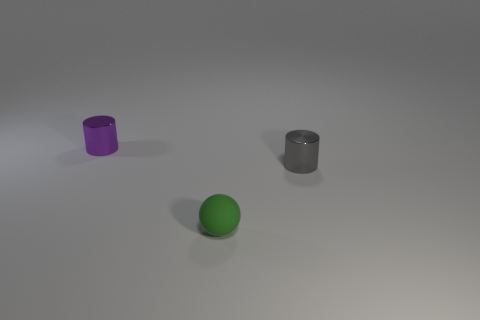Are there fewer purple metallic things that are to the right of the tiny rubber sphere than gray objects?
Ensure brevity in your answer.  Yes. There is a cylinder that is behind the gray metallic object; is it the same size as the green ball?
Your answer should be compact. Yes. How many things are behind the gray metal object and to the right of the tiny green object?
Your answer should be very brief. 0. What size is the cylinder to the right of the small shiny cylinder left of the tiny matte thing?
Your response must be concise. Small. Is the number of gray cylinders that are in front of the small gray cylinder less than the number of shiny cylinders that are right of the green rubber sphere?
Give a very brief answer. Yes. There is a shiny cylinder in front of the purple cylinder; does it have the same color as the cylinder that is to the left of the small green object?
Give a very brief answer. No. There is a object that is in front of the purple object and to the left of the small gray shiny object; what is its material?
Keep it short and to the point. Rubber. Are there any tiny rubber objects?
Offer a very short reply. Yes. What is the shape of the tiny gray object that is the same material as the tiny purple cylinder?
Your answer should be very brief. Cylinder. Does the purple object have the same shape as the thing that is in front of the small gray cylinder?
Your answer should be very brief. No. 